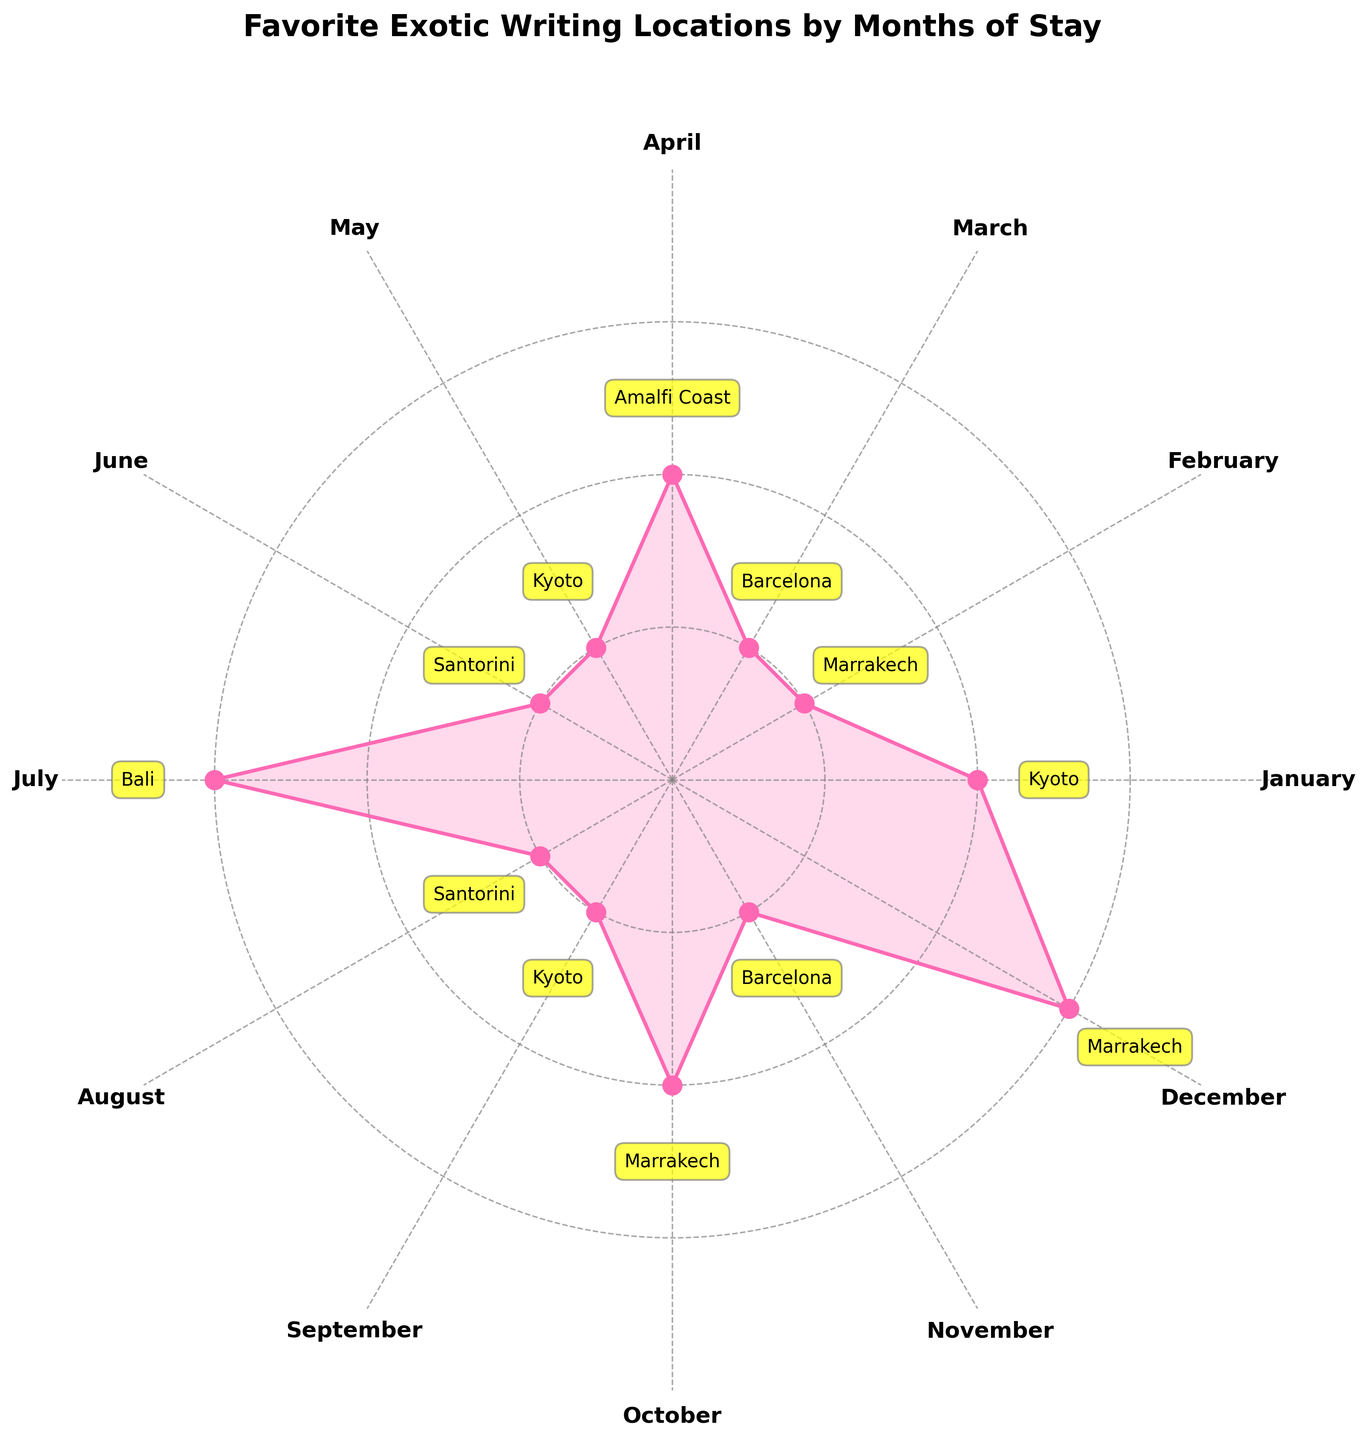What is the title of the rose chart? The title is located above the chart and provides the main theme or focus of the visualization. Looking at the figure, the title reads "Favorite Exotic Writing Locations by Months of Stay".
Answer: Favorite Exotic Writing Locations by Months of Stay Which month had the highest number of months of stay? The length of the radial bar that extends furthest from the center corresponds to the highest number of months of stay. Observing the figure, December shows the longest bar, indicating 3 months of stay.
Answer: December How many months did the novelist stay in Kyoto in total? To find the total months spent in Kyoto, we need to sum up the individual months of stay for Kyoto across all months. From January (2 months), May (1 month), and September (1 month), the total is 2 + 1 + 1 = 4 months.
Answer: 4 Which locations were visited in the summer months (June, July, August)? Summer months are June, July, and August. Looking at the corresponding sections of the chart: June (Santorini, 1 month), July (Bali, 3 months), and August (Santorini, 1 month).
Answer: Santorini and Bali Compare the total months of stay in Marrakech and Barcelona. Which one had more months? Sum the months of stay individually for Marrakech (February 1, October 2, December 3) and Barcelona (March 1, November 1). For Marrakech, it's 1 + 2 + 3 = 6 months. For Barcelona, it's 1 + 1 = 2 months.
Answer: Marrakech Which month had the shortest stay and where was it? The shortest stay corresponds to the shortest radial bar. Observing the chart, February has the shortest bar indicating 1 month of stay, which was in Marrakech.
Answer: February in Marrakech Which locations had an equal number of months of stay in the entire year? Name these locations and the total months. To find locations with equal months, compare total stays for each. From the chart: Santorini (2 months: June 1, August 1), Barcelona (2 months: March 1, November 1). Both had 2 months of stay.
Answer: Santorini and Barcelona, 2 months What was the favorite location in December? The favorite location for a month is the location with the highest number of stays for that month. According to the chart, the longest bar in December correlates with 3 months in Marrakech.
Answer: Marrakech Calculate the average months of stay per location for Amalfi Coast. Amalfi Coast appears only once in April for 2 months. To find the average: Since there's only one instance, the average is 2 / 1 = 2 months.
Answer: 2 